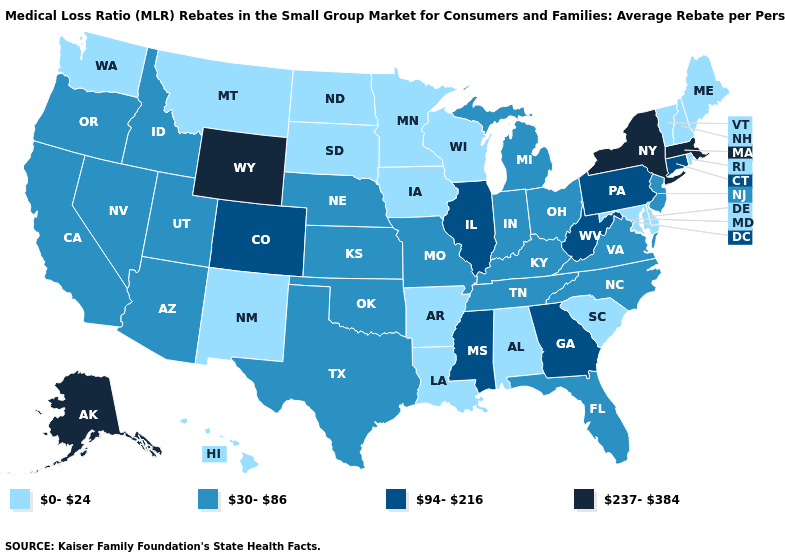Among the states that border Maine , which have the highest value?
Answer briefly. New Hampshire. Which states hav the highest value in the MidWest?
Give a very brief answer. Illinois. Name the states that have a value in the range 94-216?
Quick response, please. Colorado, Connecticut, Georgia, Illinois, Mississippi, Pennsylvania, West Virginia. Name the states that have a value in the range 0-24?
Be succinct. Alabama, Arkansas, Delaware, Hawaii, Iowa, Louisiana, Maine, Maryland, Minnesota, Montana, New Hampshire, New Mexico, North Dakota, Rhode Island, South Carolina, South Dakota, Vermont, Washington, Wisconsin. Among the states that border Iowa , which have the highest value?
Keep it brief. Illinois. Does Arkansas have the lowest value in the USA?
Be succinct. Yes. Which states hav the highest value in the South?
Answer briefly. Georgia, Mississippi, West Virginia. Among the states that border Wisconsin , which have the highest value?
Keep it brief. Illinois. Name the states that have a value in the range 94-216?
Concise answer only. Colorado, Connecticut, Georgia, Illinois, Mississippi, Pennsylvania, West Virginia. Name the states that have a value in the range 0-24?
Concise answer only. Alabama, Arkansas, Delaware, Hawaii, Iowa, Louisiana, Maine, Maryland, Minnesota, Montana, New Hampshire, New Mexico, North Dakota, Rhode Island, South Carolina, South Dakota, Vermont, Washington, Wisconsin. Does Pennsylvania have the highest value in the USA?
Write a very short answer. No. Does the map have missing data?
Write a very short answer. No. Among the states that border New Hampshire , which have the lowest value?
Keep it brief. Maine, Vermont. What is the value of Texas?
Short answer required. 30-86. What is the lowest value in the West?
Be succinct. 0-24. 